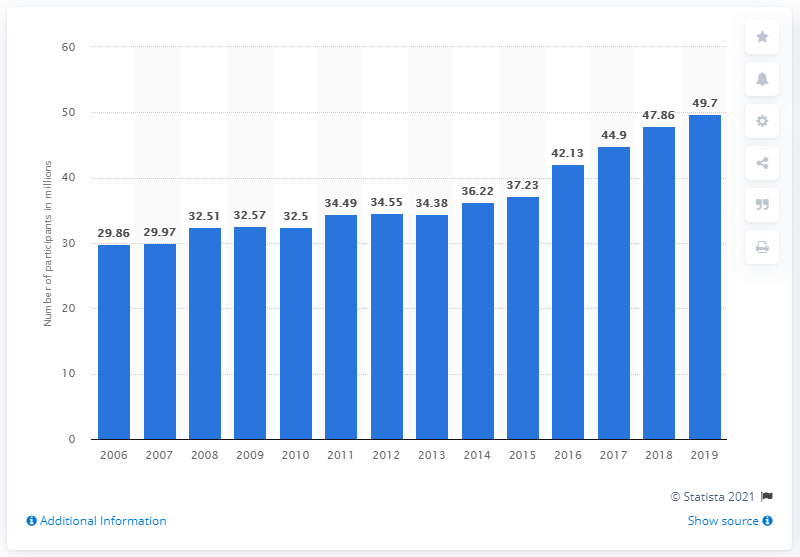Specify some key components in this picture. In 2019, there were 49.7 million hikers in the United States. 